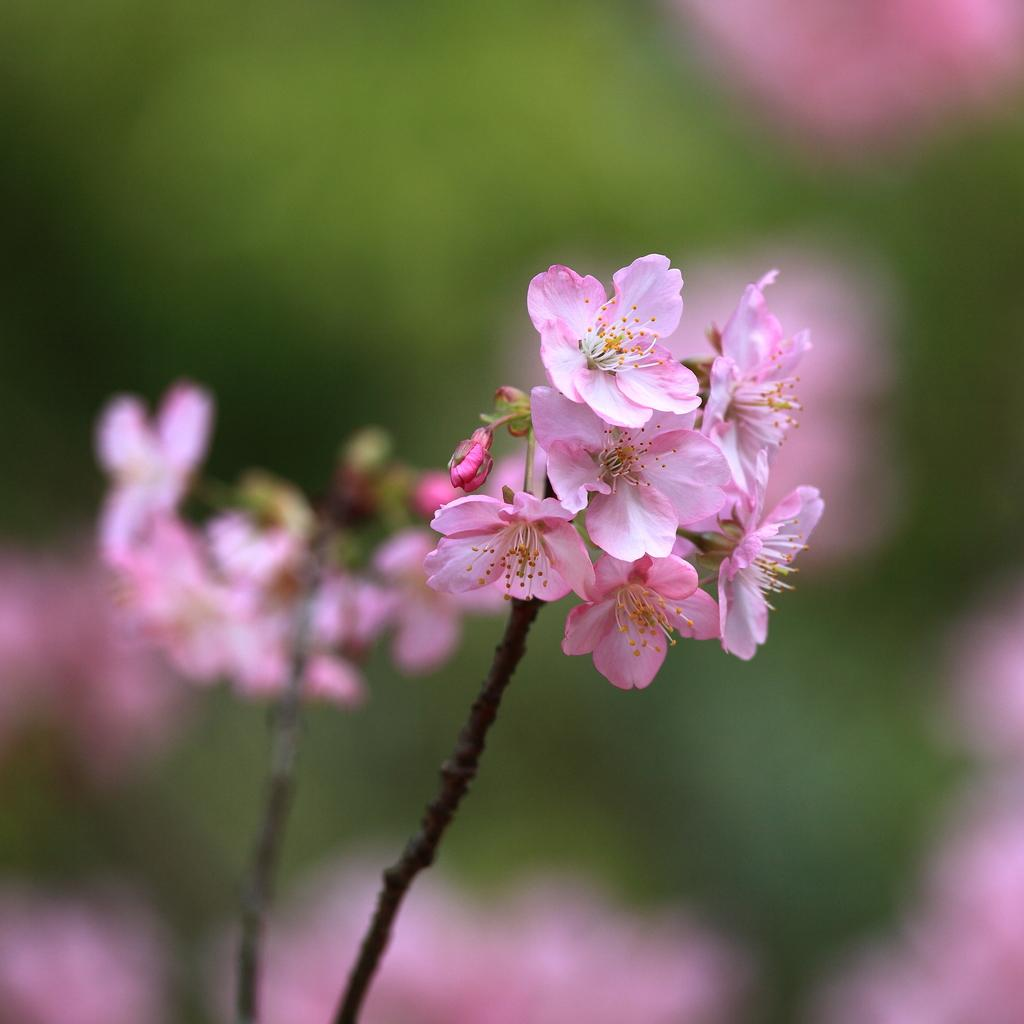What type of flowers can be seen on the plant in the image? There are pink color flowers on a plant in the image. Can you describe the background of the image? The background of the image is blurry. What type of lock is used to secure the jeans in the image? There are no jeans or locks present in the image; it only features pink color flowers on a plant with a blurry background. 